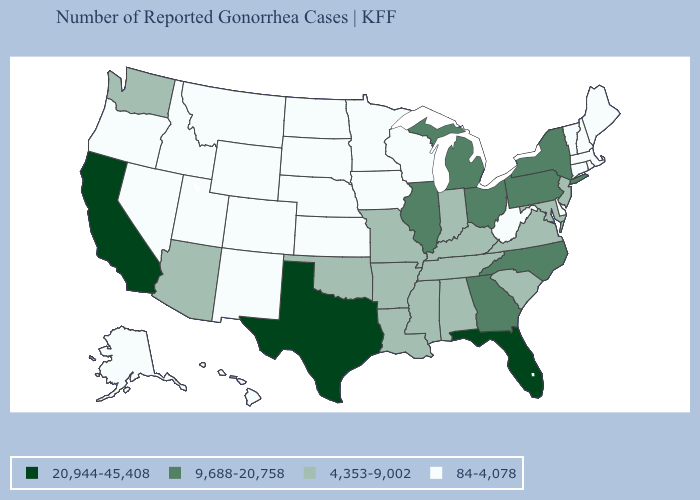Is the legend a continuous bar?
Short answer required. No. Does Texas have a higher value than California?
Quick response, please. No. How many symbols are there in the legend?
Short answer required. 4. How many symbols are there in the legend?
Be succinct. 4. Name the states that have a value in the range 9,688-20,758?
Be succinct. Georgia, Illinois, Michigan, New York, North Carolina, Ohio, Pennsylvania. Does the map have missing data?
Quick response, please. No. Does the map have missing data?
Be succinct. No. Name the states that have a value in the range 4,353-9,002?
Keep it brief. Alabama, Arizona, Arkansas, Indiana, Kentucky, Louisiana, Maryland, Mississippi, Missouri, New Jersey, Oklahoma, South Carolina, Tennessee, Virginia, Washington. Does the first symbol in the legend represent the smallest category?
Write a very short answer. No. Does the first symbol in the legend represent the smallest category?
Write a very short answer. No. Which states hav the highest value in the South?
Concise answer only. Florida, Texas. Does New Mexico have the highest value in the USA?
Keep it brief. No. Name the states that have a value in the range 84-4,078?
Give a very brief answer. Alaska, Colorado, Connecticut, Delaware, Hawaii, Idaho, Iowa, Kansas, Maine, Massachusetts, Minnesota, Montana, Nebraska, Nevada, New Hampshire, New Mexico, North Dakota, Oregon, Rhode Island, South Dakota, Utah, Vermont, West Virginia, Wisconsin, Wyoming. Does Nevada have the lowest value in the USA?
Keep it brief. Yes. Does Pennsylvania have the lowest value in the Northeast?
Quick response, please. No. 